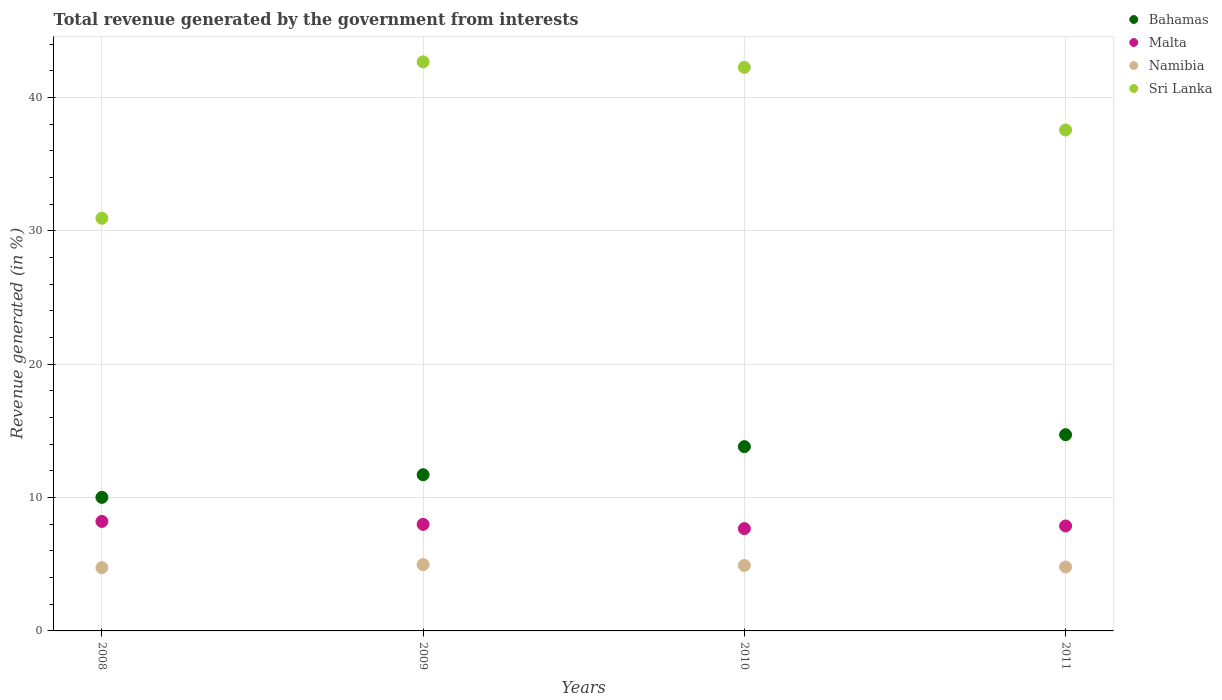Is the number of dotlines equal to the number of legend labels?
Your answer should be very brief. Yes. What is the total revenue generated in Bahamas in 2009?
Ensure brevity in your answer.  11.71. Across all years, what is the maximum total revenue generated in Malta?
Give a very brief answer. 8.21. Across all years, what is the minimum total revenue generated in Malta?
Keep it short and to the point. 7.67. In which year was the total revenue generated in Sri Lanka maximum?
Provide a succinct answer. 2009. What is the total total revenue generated in Malta in the graph?
Your answer should be very brief. 31.75. What is the difference between the total revenue generated in Malta in 2009 and that in 2011?
Offer a very short reply. 0.12. What is the difference between the total revenue generated in Bahamas in 2011 and the total revenue generated in Malta in 2009?
Give a very brief answer. 6.72. What is the average total revenue generated in Bahamas per year?
Your answer should be very brief. 12.57. In the year 2009, what is the difference between the total revenue generated in Sri Lanka and total revenue generated in Bahamas?
Your answer should be very brief. 30.97. What is the ratio of the total revenue generated in Sri Lanka in 2009 to that in 2010?
Make the answer very short. 1.01. Is the total revenue generated in Sri Lanka in 2008 less than that in 2011?
Ensure brevity in your answer.  Yes. Is the difference between the total revenue generated in Sri Lanka in 2008 and 2009 greater than the difference between the total revenue generated in Bahamas in 2008 and 2009?
Your answer should be very brief. No. What is the difference between the highest and the second highest total revenue generated in Malta?
Ensure brevity in your answer.  0.22. What is the difference between the highest and the lowest total revenue generated in Bahamas?
Make the answer very short. 4.7. In how many years, is the total revenue generated in Malta greater than the average total revenue generated in Malta taken over all years?
Provide a succinct answer. 2. Does the total revenue generated in Malta monotonically increase over the years?
Offer a terse response. No. Is the total revenue generated in Sri Lanka strictly greater than the total revenue generated in Namibia over the years?
Ensure brevity in your answer.  Yes. How many dotlines are there?
Provide a short and direct response. 4. What is the difference between two consecutive major ticks on the Y-axis?
Provide a succinct answer. 10. Are the values on the major ticks of Y-axis written in scientific E-notation?
Ensure brevity in your answer.  No. Where does the legend appear in the graph?
Your answer should be very brief. Top right. How many legend labels are there?
Give a very brief answer. 4. How are the legend labels stacked?
Give a very brief answer. Vertical. What is the title of the graph?
Ensure brevity in your answer.  Total revenue generated by the government from interests. What is the label or title of the X-axis?
Provide a succinct answer. Years. What is the label or title of the Y-axis?
Your response must be concise. Revenue generated (in %). What is the Revenue generated (in %) in Bahamas in 2008?
Keep it short and to the point. 10.02. What is the Revenue generated (in %) of Malta in 2008?
Keep it short and to the point. 8.21. What is the Revenue generated (in %) of Namibia in 2008?
Make the answer very short. 4.75. What is the Revenue generated (in %) in Sri Lanka in 2008?
Ensure brevity in your answer.  30.95. What is the Revenue generated (in %) of Bahamas in 2009?
Offer a terse response. 11.71. What is the Revenue generated (in %) of Malta in 2009?
Give a very brief answer. 7.99. What is the Revenue generated (in %) in Namibia in 2009?
Offer a very short reply. 4.98. What is the Revenue generated (in %) of Sri Lanka in 2009?
Your answer should be very brief. 42.68. What is the Revenue generated (in %) in Bahamas in 2010?
Offer a very short reply. 13.82. What is the Revenue generated (in %) in Malta in 2010?
Your response must be concise. 7.67. What is the Revenue generated (in %) of Namibia in 2010?
Keep it short and to the point. 4.91. What is the Revenue generated (in %) of Sri Lanka in 2010?
Offer a very short reply. 42.27. What is the Revenue generated (in %) in Bahamas in 2011?
Make the answer very short. 14.72. What is the Revenue generated (in %) in Malta in 2011?
Ensure brevity in your answer.  7.87. What is the Revenue generated (in %) of Namibia in 2011?
Your answer should be compact. 4.8. What is the Revenue generated (in %) in Sri Lanka in 2011?
Ensure brevity in your answer.  37.57. Across all years, what is the maximum Revenue generated (in %) of Bahamas?
Your answer should be very brief. 14.72. Across all years, what is the maximum Revenue generated (in %) in Malta?
Keep it short and to the point. 8.21. Across all years, what is the maximum Revenue generated (in %) of Namibia?
Provide a succinct answer. 4.98. Across all years, what is the maximum Revenue generated (in %) in Sri Lanka?
Make the answer very short. 42.68. Across all years, what is the minimum Revenue generated (in %) of Bahamas?
Offer a very short reply. 10.02. Across all years, what is the minimum Revenue generated (in %) in Malta?
Keep it short and to the point. 7.67. Across all years, what is the minimum Revenue generated (in %) of Namibia?
Offer a very short reply. 4.75. Across all years, what is the minimum Revenue generated (in %) in Sri Lanka?
Ensure brevity in your answer.  30.95. What is the total Revenue generated (in %) of Bahamas in the graph?
Offer a terse response. 50.27. What is the total Revenue generated (in %) of Malta in the graph?
Ensure brevity in your answer.  31.75. What is the total Revenue generated (in %) of Namibia in the graph?
Offer a terse response. 19.43. What is the total Revenue generated (in %) in Sri Lanka in the graph?
Your response must be concise. 153.47. What is the difference between the Revenue generated (in %) of Bahamas in 2008 and that in 2009?
Your response must be concise. -1.7. What is the difference between the Revenue generated (in %) of Malta in 2008 and that in 2009?
Offer a very short reply. 0.22. What is the difference between the Revenue generated (in %) in Namibia in 2008 and that in 2009?
Provide a succinct answer. -0.23. What is the difference between the Revenue generated (in %) in Sri Lanka in 2008 and that in 2009?
Make the answer very short. -11.73. What is the difference between the Revenue generated (in %) of Bahamas in 2008 and that in 2010?
Make the answer very short. -3.8. What is the difference between the Revenue generated (in %) in Malta in 2008 and that in 2010?
Offer a terse response. 0.54. What is the difference between the Revenue generated (in %) in Namibia in 2008 and that in 2010?
Keep it short and to the point. -0.17. What is the difference between the Revenue generated (in %) in Sri Lanka in 2008 and that in 2010?
Make the answer very short. -11.32. What is the difference between the Revenue generated (in %) of Bahamas in 2008 and that in 2011?
Ensure brevity in your answer.  -4.7. What is the difference between the Revenue generated (in %) in Malta in 2008 and that in 2011?
Offer a very short reply. 0.34. What is the difference between the Revenue generated (in %) in Namibia in 2008 and that in 2011?
Keep it short and to the point. -0.05. What is the difference between the Revenue generated (in %) in Sri Lanka in 2008 and that in 2011?
Ensure brevity in your answer.  -6.62. What is the difference between the Revenue generated (in %) in Bahamas in 2009 and that in 2010?
Keep it short and to the point. -2.11. What is the difference between the Revenue generated (in %) in Malta in 2009 and that in 2010?
Your answer should be compact. 0.32. What is the difference between the Revenue generated (in %) in Namibia in 2009 and that in 2010?
Make the answer very short. 0.06. What is the difference between the Revenue generated (in %) of Sri Lanka in 2009 and that in 2010?
Keep it short and to the point. 0.41. What is the difference between the Revenue generated (in %) in Bahamas in 2009 and that in 2011?
Provide a succinct answer. -3. What is the difference between the Revenue generated (in %) in Malta in 2009 and that in 2011?
Keep it short and to the point. 0.12. What is the difference between the Revenue generated (in %) of Namibia in 2009 and that in 2011?
Your response must be concise. 0.18. What is the difference between the Revenue generated (in %) of Sri Lanka in 2009 and that in 2011?
Provide a succinct answer. 5.11. What is the difference between the Revenue generated (in %) in Bahamas in 2010 and that in 2011?
Provide a short and direct response. -0.9. What is the difference between the Revenue generated (in %) of Malta in 2010 and that in 2011?
Your answer should be compact. -0.2. What is the difference between the Revenue generated (in %) of Namibia in 2010 and that in 2011?
Give a very brief answer. 0.11. What is the difference between the Revenue generated (in %) in Sri Lanka in 2010 and that in 2011?
Give a very brief answer. 4.7. What is the difference between the Revenue generated (in %) in Bahamas in 2008 and the Revenue generated (in %) in Malta in 2009?
Provide a succinct answer. 2.03. What is the difference between the Revenue generated (in %) of Bahamas in 2008 and the Revenue generated (in %) of Namibia in 2009?
Provide a succinct answer. 5.04. What is the difference between the Revenue generated (in %) of Bahamas in 2008 and the Revenue generated (in %) of Sri Lanka in 2009?
Keep it short and to the point. -32.66. What is the difference between the Revenue generated (in %) of Malta in 2008 and the Revenue generated (in %) of Namibia in 2009?
Offer a very short reply. 3.24. What is the difference between the Revenue generated (in %) in Malta in 2008 and the Revenue generated (in %) in Sri Lanka in 2009?
Your answer should be very brief. -34.47. What is the difference between the Revenue generated (in %) in Namibia in 2008 and the Revenue generated (in %) in Sri Lanka in 2009?
Your response must be concise. -37.94. What is the difference between the Revenue generated (in %) in Bahamas in 2008 and the Revenue generated (in %) in Malta in 2010?
Your answer should be compact. 2.34. What is the difference between the Revenue generated (in %) of Bahamas in 2008 and the Revenue generated (in %) of Namibia in 2010?
Ensure brevity in your answer.  5.11. What is the difference between the Revenue generated (in %) of Bahamas in 2008 and the Revenue generated (in %) of Sri Lanka in 2010?
Keep it short and to the point. -32.25. What is the difference between the Revenue generated (in %) of Malta in 2008 and the Revenue generated (in %) of Namibia in 2010?
Your response must be concise. 3.3. What is the difference between the Revenue generated (in %) of Malta in 2008 and the Revenue generated (in %) of Sri Lanka in 2010?
Provide a succinct answer. -34.05. What is the difference between the Revenue generated (in %) in Namibia in 2008 and the Revenue generated (in %) in Sri Lanka in 2010?
Your response must be concise. -37.52. What is the difference between the Revenue generated (in %) of Bahamas in 2008 and the Revenue generated (in %) of Malta in 2011?
Provide a short and direct response. 2.15. What is the difference between the Revenue generated (in %) in Bahamas in 2008 and the Revenue generated (in %) in Namibia in 2011?
Your response must be concise. 5.22. What is the difference between the Revenue generated (in %) of Bahamas in 2008 and the Revenue generated (in %) of Sri Lanka in 2011?
Give a very brief answer. -27.55. What is the difference between the Revenue generated (in %) in Malta in 2008 and the Revenue generated (in %) in Namibia in 2011?
Make the answer very short. 3.42. What is the difference between the Revenue generated (in %) of Malta in 2008 and the Revenue generated (in %) of Sri Lanka in 2011?
Offer a very short reply. -29.36. What is the difference between the Revenue generated (in %) of Namibia in 2008 and the Revenue generated (in %) of Sri Lanka in 2011?
Make the answer very short. -32.83. What is the difference between the Revenue generated (in %) of Bahamas in 2009 and the Revenue generated (in %) of Malta in 2010?
Give a very brief answer. 4.04. What is the difference between the Revenue generated (in %) of Bahamas in 2009 and the Revenue generated (in %) of Namibia in 2010?
Provide a succinct answer. 6.8. What is the difference between the Revenue generated (in %) in Bahamas in 2009 and the Revenue generated (in %) in Sri Lanka in 2010?
Offer a terse response. -30.55. What is the difference between the Revenue generated (in %) of Malta in 2009 and the Revenue generated (in %) of Namibia in 2010?
Provide a succinct answer. 3.08. What is the difference between the Revenue generated (in %) of Malta in 2009 and the Revenue generated (in %) of Sri Lanka in 2010?
Keep it short and to the point. -34.28. What is the difference between the Revenue generated (in %) in Namibia in 2009 and the Revenue generated (in %) in Sri Lanka in 2010?
Give a very brief answer. -37.29. What is the difference between the Revenue generated (in %) of Bahamas in 2009 and the Revenue generated (in %) of Malta in 2011?
Make the answer very short. 3.84. What is the difference between the Revenue generated (in %) of Bahamas in 2009 and the Revenue generated (in %) of Namibia in 2011?
Your answer should be compact. 6.92. What is the difference between the Revenue generated (in %) of Bahamas in 2009 and the Revenue generated (in %) of Sri Lanka in 2011?
Ensure brevity in your answer.  -25.86. What is the difference between the Revenue generated (in %) of Malta in 2009 and the Revenue generated (in %) of Namibia in 2011?
Keep it short and to the point. 3.19. What is the difference between the Revenue generated (in %) in Malta in 2009 and the Revenue generated (in %) in Sri Lanka in 2011?
Give a very brief answer. -29.58. What is the difference between the Revenue generated (in %) in Namibia in 2009 and the Revenue generated (in %) in Sri Lanka in 2011?
Your response must be concise. -32.6. What is the difference between the Revenue generated (in %) of Bahamas in 2010 and the Revenue generated (in %) of Malta in 2011?
Keep it short and to the point. 5.95. What is the difference between the Revenue generated (in %) of Bahamas in 2010 and the Revenue generated (in %) of Namibia in 2011?
Make the answer very short. 9.02. What is the difference between the Revenue generated (in %) in Bahamas in 2010 and the Revenue generated (in %) in Sri Lanka in 2011?
Provide a succinct answer. -23.75. What is the difference between the Revenue generated (in %) in Malta in 2010 and the Revenue generated (in %) in Namibia in 2011?
Make the answer very short. 2.88. What is the difference between the Revenue generated (in %) of Malta in 2010 and the Revenue generated (in %) of Sri Lanka in 2011?
Offer a very short reply. -29.9. What is the difference between the Revenue generated (in %) in Namibia in 2010 and the Revenue generated (in %) in Sri Lanka in 2011?
Your answer should be very brief. -32.66. What is the average Revenue generated (in %) of Bahamas per year?
Your response must be concise. 12.57. What is the average Revenue generated (in %) in Malta per year?
Make the answer very short. 7.94. What is the average Revenue generated (in %) of Namibia per year?
Provide a succinct answer. 4.86. What is the average Revenue generated (in %) in Sri Lanka per year?
Ensure brevity in your answer.  38.37. In the year 2008, what is the difference between the Revenue generated (in %) of Bahamas and Revenue generated (in %) of Malta?
Keep it short and to the point. 1.8. In the year 2008, what is the difference between the Revenue generated (in %) of Bahamas and Revenue generated (in %) of Namibia?
Provide a succinct answer. 5.27. In the year 2008, what is the difference between the Revenue generated (in %) in Bahamas and Revenue generated (in %) in Sri Lanka?
Give a very brief answer. -20.93. In the year 2008, what is the difference between the Revenue generated (in %) in Malta and Revenue generated (in %) in Namibia?
Offer a very short reply. 3.47. In the year 2008, what is the difference between the Revenue generated (in %) in Malta and Revenue generated (in %) in Sri Lanka?
Offer a terse response. -22.74. In the year 2008, what is the difference between the Revenue generated (in %) of Namibia and Revenue generated (in %) of Sri Lanka?
Give a very brief answer. -26.21. In the year 2009, what is the difference between the Revenue generated (in %) of Bahamas and Revenue generated (in %) of Malta?
Ensure brevity in your answer.  3.72. In the year 2009, what is the difference between the Revenue generated (in %) of Bahamas and Revenue generated (in %) of Namibia?
Provide a short and direct response. 6.74. In the year 2009, what is the difference between the Revenue generated (in %) of Bahamas and Revenue generated (in %) of Sri Lanka?
Give a very brief answer. -30.97. In the year 2009, what is the difference between the Revenue generated (in %) in Malta and Revenue generated (in %) in Namibia?
Ensure brevity in your answer.  3.02. In the year 2009, what is the difference between the Revenue generated (in %) of Malta and Revenue generated (in %) of Sri Lanka?
Offer a terse response. -34.69. In the year 2009, what is the difference between the Revenue generated (in %) of Namibia and Revenue generated (in %) of Sri Lanka?
Offer a very short reply. -37.71. In the year 2010, what is the difference between the Revenue generated (in %) in Bahamas and Revenue generated (in %) in Malta?
Provide a succinct answer. 6.15. In the year 2010, what is the difference between the Revenue generated (in %) of Bahamas and Revenue generated (in %) of Namibia?
Keep it short and to the point. 8.91. In the year 2010, what is the difference between the Revenue generated (in %) in Bahamas and Revenue generated (in %) in Sri Lanka?
Offer a very short reply. -28.45. In the year 2010, what is the difference between the Revenue generated (in %) in Malta and Revenue generated (in %) in Namibia?
Provide a short and direct response. 2.76. In the year 2010, what is the difference between the Revenue generated (in %) of Malta and Revenue generated (in %) of Sri Lanka?
Offer a very short reply. -34.59. In the year 2010, what is the difference between the Revenue generated (in %) in Namibia and Revenue generated (in %) in Sri Lanka?
Offer a terse response. -37.36. In the year 2011, what is the difference between the Revenue generated (in %) of Bahamas and Revenue generated (in %) of Malta?
Give a very brief answer. 6.85. In the year 2011, what is the difference between the Revenue generated (in %) in Bahamas and Revenue generated (in %) in Namibia?
Provide a succinct answer. 9.92. In the year 2011, what is the difference between the Revenue generated (in %) in Bahamas and Revenue generated (in %) in Sri Lanka?
Your answer should be compact. -22.85. In the year 2011, what is the difference between the Revenue generated (in %) of Malta and Revenue generated (in %) of Namibia?
Your answer should be very brief. 3.07. In the year 2011, what is the difference between the Revenue generated (in %) of Malta and Revenue generated (in %) of Sri Lanka?
Your answer should be very brief. -29.7. In the year 2011, what is the difference between the Revenue generated (in %) in Namibia and Revenue generated (in %) in Sri Lanka?
Your response must be concise. -32.77. What is the ratio of the Revenue generated (in %) in Bahamas in 2008 to that in 2009?
Provide a succinct answer. 0.86. What is the ratio of the Revenue generated (in %) in Malta in 2008 to that in 2009?
Make the answer very short. 1.03. What is the ratio of the Revenue generated (in %) of Namibia in 2008 to that in 2009?
Your response must be concise. 0.95. What is the ratio of the Revenue generated (in %) of Sri Lanka in 2008 to that in 2009?
Ensure brevity in your answer.  0.73. What is the ratio of the Revenue generated (in %) of Bahamas in 2008 to that in 2010?
Provide a short and direct response. 0.72. What is the ratio of the Revenue generated (in %) of Malta in 2008 to that in 2010?
Provide a succinct answer. 1.07. What is the ratio of the Revenue generated (in %) of Namibia in 2008 to that in 2010?
Your answer should be very brief. 0.97. What is the ratio of the Revenue generated (in %) in Sri Lanka in 2008 to that in 2010?
Keep it short and to the point. 0.73. What is the ratio of the Revenue generated (in %) of Bahamas in 2008 to that in 2011?
Give a very brief answer. 0.68. What is the ratio of the Revenue generated (in %) in Malta in 2008 to that in 2011?
Make the answer very short. 1.04. What is the ratio of the Revenue generated (in %) in Namibia in 2008 to that in 2011?
Your response must be concise. 0.99. What is the ratio of the Revenue generated (in %) in Sri Lanka in 2008 to that in 2011?
Provide a short and direct response. 0.82. What is the ratio of the Revenue generated (in %) of Bahamas in 2009 to that in 2010?
Your answer should be very brief. 0.85. What is the ratio of the Revenue generated (in %) of Malta in 2009 to that in 2010?
Keep it short and to the point. 1.04. What is the ratio of the Revenue generated (in %) in Namibia in 2009 to that in 2010?
Your answer should be very brief. 1.01. What is the ratio of the Revenue generated (in %) of Sri Lanka in 2009 to that in 2010?
Offer a terse response. 1.01. What is the ratio of the Revenue generated (in %) of Bahamas in 2009 to that in 2011?
Offer a very short reply. 0.8. What is the ratio of the Revenue generated (in %) in Malta in 2009 to that in 2011?
Your response must be concise. 1.02. What is the ratio of the Revenue generated (in %) in Namibia in 2009 to that in 2011?
Your response must be concise. 1.04. What is the ratio of the Revenue generated (in %) in Sri Lanka in 2009 to that in 2011?
Offer a terse response. 1.14. What is the ratio of the Revenue generated (in %) of Bahamas in 2010 to that in 2011?
Ensure brevity in your answer.  0.94. What is the ratio of the Revenue generated (in %) of Malta in 2010 to that in 2011?
Give a very brief answer. 0.98. What is the ratio of the Revenue generated (in %) in Namibia in 2010 to that in 2011?
Provide a short and direct response. 1.02. What is the ratio of the Revenue generated (in %) in Sri Lanka in 2010 to that in 2011?
Keep it short and to the point. 1.12. What is the difference between the highest and the second highest Revenue generated (in %) in Bahamas?
Give a very brief answer. 0.9. What is the difference between the highest and the second highest Revenue generated (in %) of Malta?
Ensure brevity in your answer.  0.22. What is the difference between the highest and the second highest Revenue generated (in %) in Namibia?
Provide a succinct answer. 0.06. What is the difference between the highest and the second highest Revenue generated (in %) of Sri Lanka?
Your response must be concise. 0.41. What is the difference between the highest and the lowest Revenue generated (in %) of Bahamas?
Your answer should be very brief. 4.7. What is the difference between the highest and the lowest Revenue generated (in %) in Malta?
Your response must be concise. 0.54. What is the difference between the highest and the lowest Revenue generated (in %) of Namibia?
Make the answer very short. 0.23. What is the difference between the highest and the lowest Revenue generated (in %) in Sri Lanka?
Ensure brevity in your answer.  11.73. 